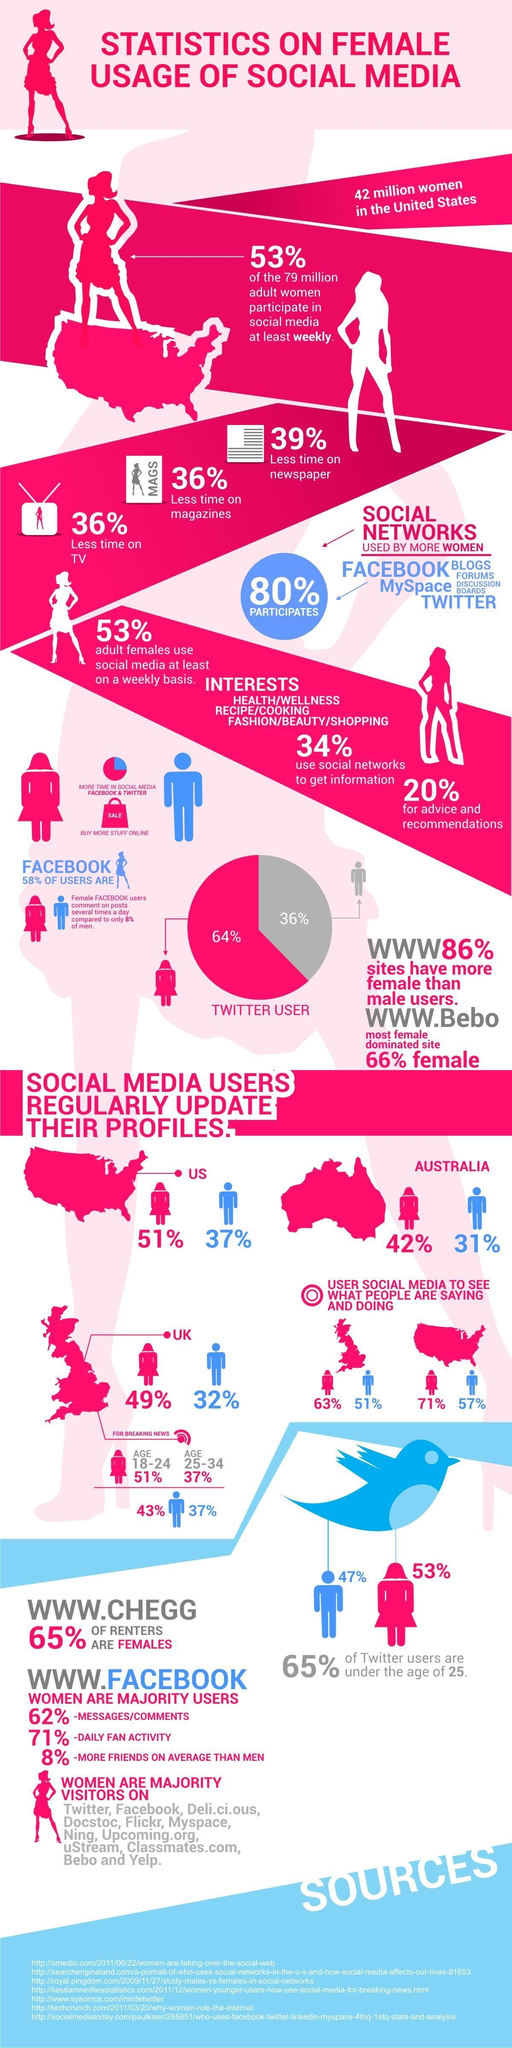What percentage of women in the UK use social media to know what others are doing?
Answer the question with a short phrase. 63% What percentage of women in the UK use social media for watching breaking news? 43% Which country has the lowest percentage of men Social Media, UK, US, or Australia? Australia 